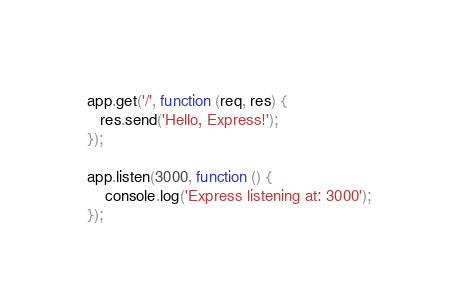<code> <loc_0><loc_0><loc_500><loc_500><_JavaScript_>app.get('/', function (req, res) {
   res.send('Hello, Express!');
});

app.listen(3000, function () {
    console.log('Express listening at: 3000');
});
</code> 